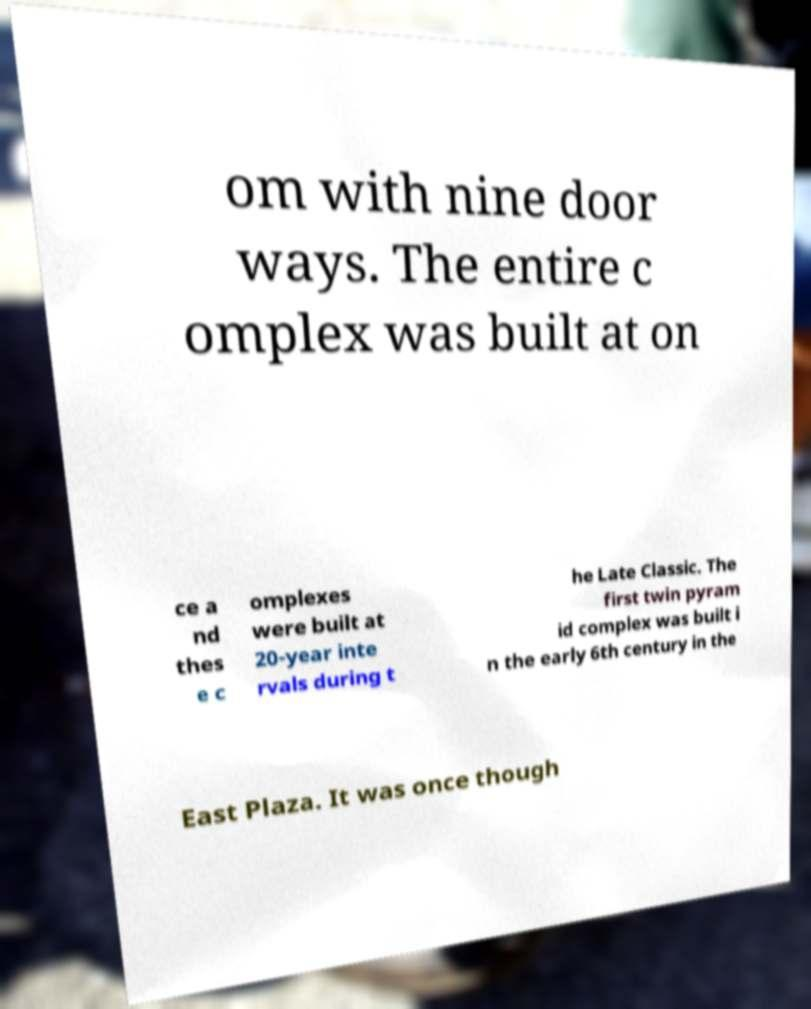There's text embedded in this image that I need extracted. Can you transcribe it verbatim? om with nine door ways. The entire c omplex was built at on ce a nd thes e c omplexes were built at 20-year inte rvals during t he Late Classic. The first twin pyram id complex was built i n the early 6th century in the East Plaza. It was once though 